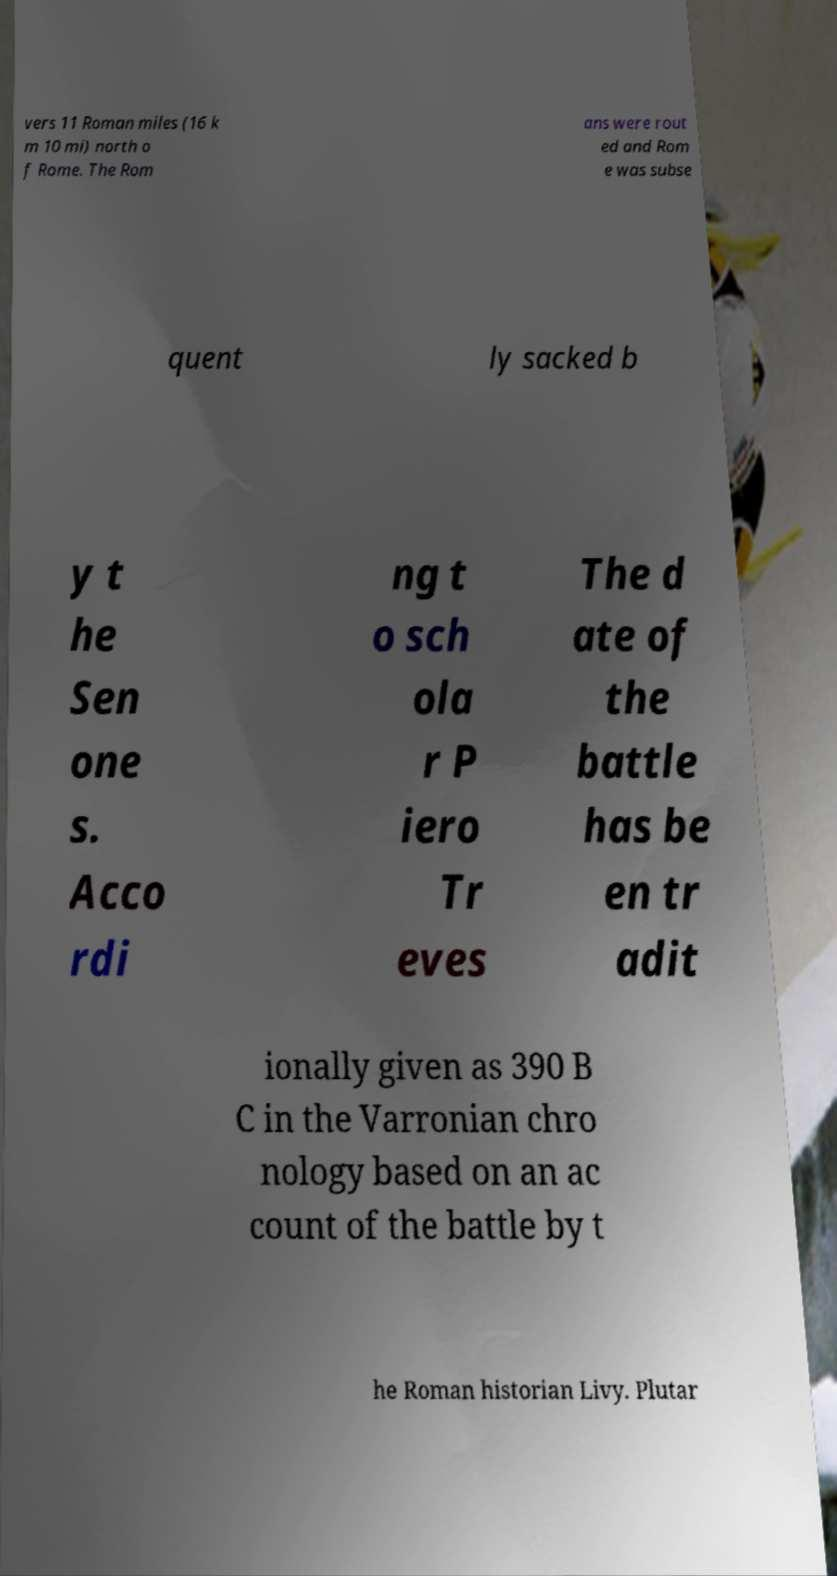I need the written content from this picture converted into text. Can you do that? vers 11 Roman miles (16 k m 10 mi) north o f Rome. The Rom ans were rout ed and Rom e was subse quent ly sacked b y t he Sen one s. Acco rdi ng t o sch ola r P iero Tr eves The d ate of the battle has be en tr adit ionally given as 390 B C in the Varronian chro nology based on an ac count of the battle by t he Roman historian Livy. Plutar 